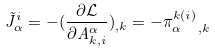Convert formula to latex. <formula><loc_0><loc_0><loc_500><loc_500>\tilde { J } ^ { i } _ { \alpha } = - ( \frac { \partial \mathcal { L } } { \partial A ^ { \alpha } _ { k , i } } ) _ { , k } = - \pi ^ { k ( i ) } _ { \alpha \ \ , k }</formula> 